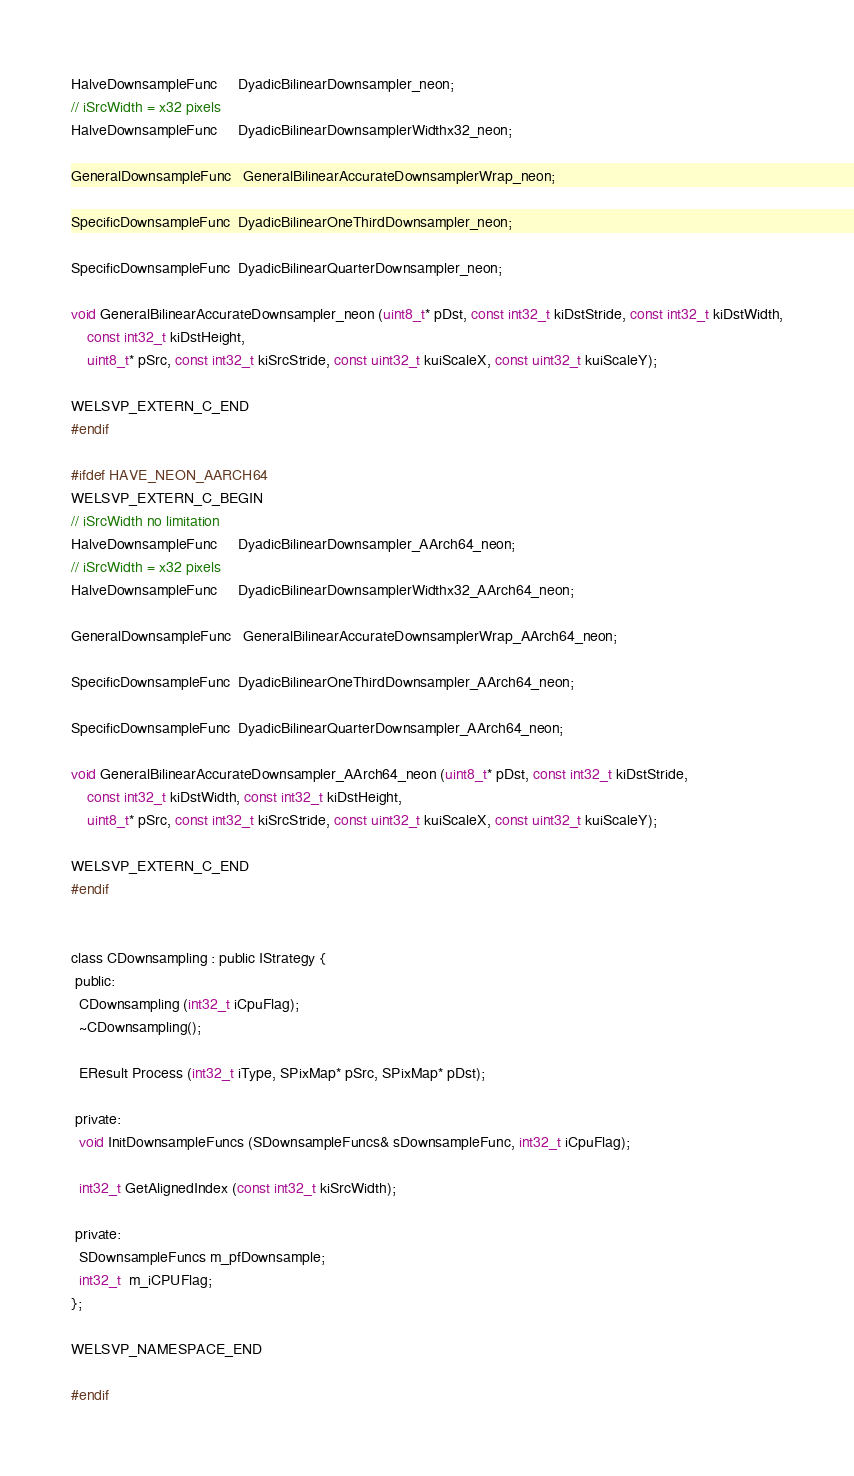<code> <loc_0><loc_0><loc_500><loc_500><_C_>HalveDownsampleFunc     DyadicBilinearDownsampler_neon;
// iSrcWidth = x32 pixels
HalveDownsampleFunc     DyadicBilinearDownsamplerWidthx32_neon;

GeneralDownsampleFunc   GeneralBilinearAccurateDownsamplerWrap_neon;

SpecificDownsampleFunc  DyadicBilinearOneThirdDownsampler_neon;

SpecificDownsampleFunc  DyadicBilinearQuarterDownsampler_neon;

void GeneralBilinearAccurateDownsampler_neon (uint8_t* pDst, const int32_t kiDstStride, const int32_t kiDstWidth,
    const int32_t kiDstHeight,
    uint8_t* pSrc, const int32_t kiSrcStride, const uint32_t kuiScaleX, const uint32_t kuiScaleY);

WELSVP_EXTERN_C_END
#endif

#ifdef HAVE_NEON_AARCH64
WELSVP_EXTERN_C_BEGIN
// iSrcWidth no limitation
HalveDownsampleFunc     DyadicBilinearDownsampler_AArch64_neon;
// iSrcWidth = x32 pixels
HalveDownsampleFunc     DyadicBilinearDownsamplerWidthx32_AArch64_neon;

GeneralDownsampleFunc   GeneralBilinearAccurateDownsamplerWrap_AArch64_neon;

SpecificDownsampleFunc  DyadicBilinearOneThirdDownsampler_AArch64_neon;

SpecificDownsampleFunc  DyadicBilinearQuarterDownsampler_AArch64_neon;

void GeneralBilinearAccurateDownsampler_AArch64_neon (uint8_t* pDst, const int32_t kiDstStride,
    const int32_t kiDstWidth, const int32_t kiDstHeight,
    uint8_t* pSrc, const int32_t kiSrcStride, const uint32_t kuiScaleX, const uint32_t kuiScaleY);

WELSVP_EXTERN_C_END
#endif


class CDownsampling : public IStrategy {
 public:
  CDownsampling (int32_t iCpuFlag);
  ~CDownsampling();

  EResult Process (int32_t iType, SPixMap* pSrc, SPixMap* pDst);

 private:
  void InitDownsampleFuncs (SDownsampleFuncs& sDownsampleFunc, int32_t iCpuFlag);

  int32_t GetAlignedIndex (const int32_t kiSrcWidth);

 private:
  SDownsampleFuncs m_pfDownsample;
  int32_t  m_iCPUFlag;
};

WELSVP_NAMESPACE_END

#endif
</code> 